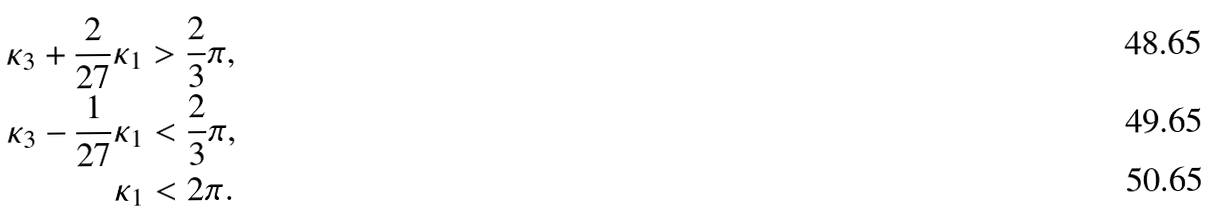Convert formula to latex. <formula><loc_0><loc_0><loc_500><loc_500>\kappa _ { 3 } + \frac { 2 } { 2 7 } \kappa _ { 1 } & > \frac { 2 } { 3 } \pi , \\ \kappa _ { 3 } - \frac { 1 } { 2 7 } \kappa _ { 1 } & < \frac { 2 } { 3 } \pi , \\ \kappa _ { 1 } & < 2 \pi .</formula> 